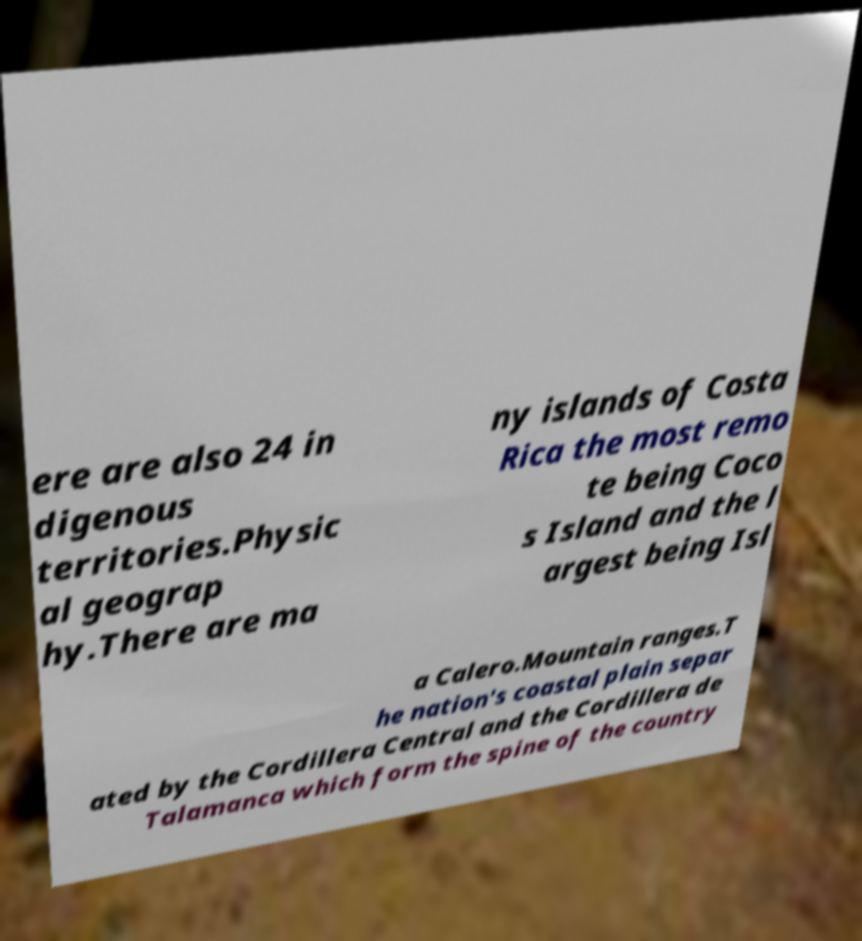Could you assist in decoding the text presented in this image and type it out clearly? ere are also 24 in digenous territories.Physic al geograp hy.There are ma ny islands of Costa Rica the most remo te being Coco s Island and the l argest being Isl a Calero.Mountain ranges.T he nation's coastal plain separ ated by the Cordillera Central and the Cordillera de Talamanca which form the spine of the country 